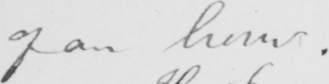Please provide the text content of this handwritten line. of an hour . 